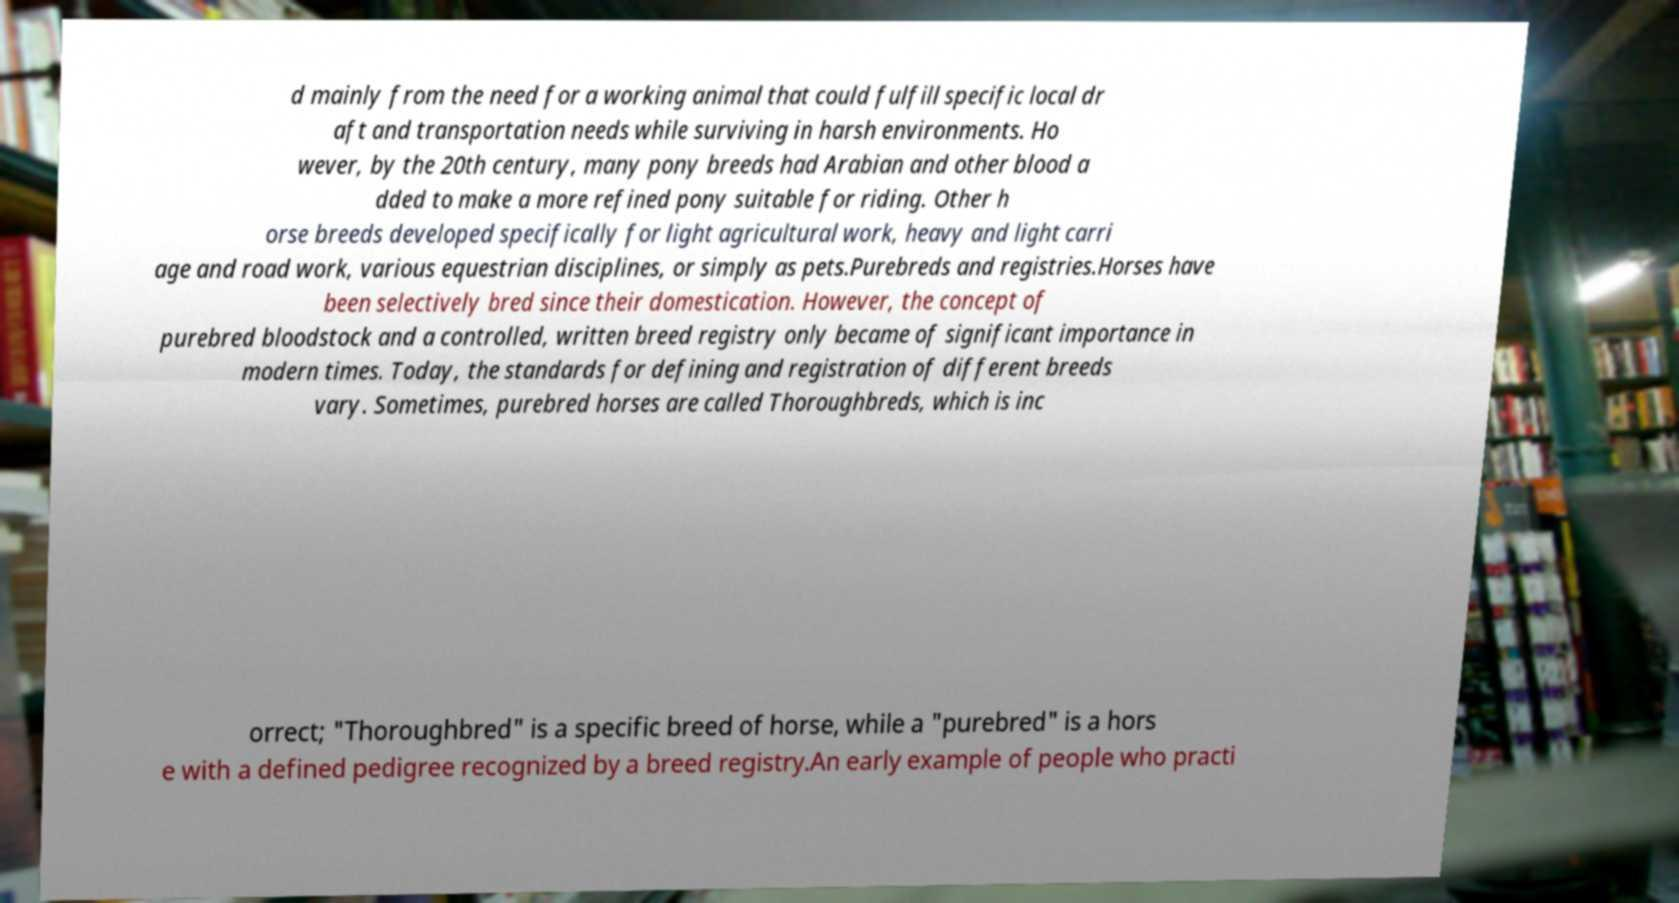Can you accurately transcribe the text from the provided image for me? d mainly from the need for a working animal that could fulfill specific local dr aft and transportation needs while surviving in harsh environments. Ho wever, by the 20th century, many pony breeds had Arabian and other blood a dded to make a more refined pony suitable for riding. Other h orse breeds developed specifically for light agricultural work, heavy and light carri age and road work, various equestrian disciplines, or simply as pets.Purebreds and registries.Horses have been selectively bred since their domestication. However, the concept of purebred bloodstock and a controlled, written breed registry only became of significant importance in modern times. Today, the standards for defining and registration of different breeds vary. Sometimes, purebred horses are called Thoroughbreds, which is inc orrect; "Thoroughbred" is a specific breed of horse, while a "purebred" is a hors e with a defined pedigree recognized by a breed registry.An early example of people who practi 